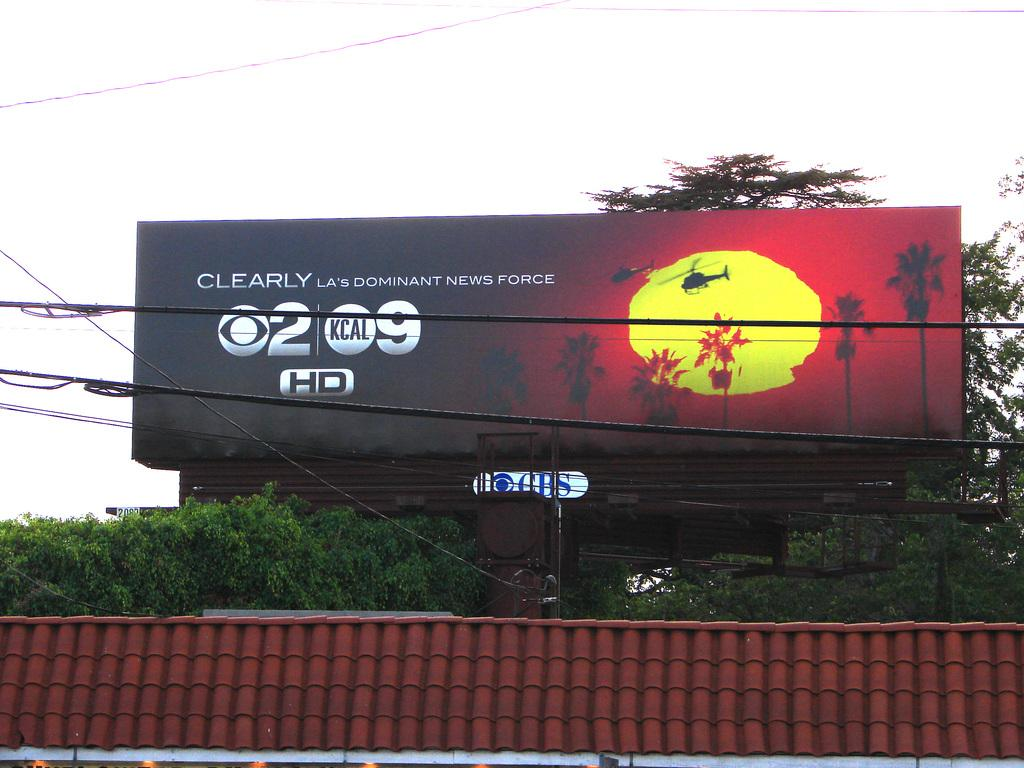<image>
Give a short and clear explanation of the subsequent image. a billboard that says 'clearly la's dominant news force' 